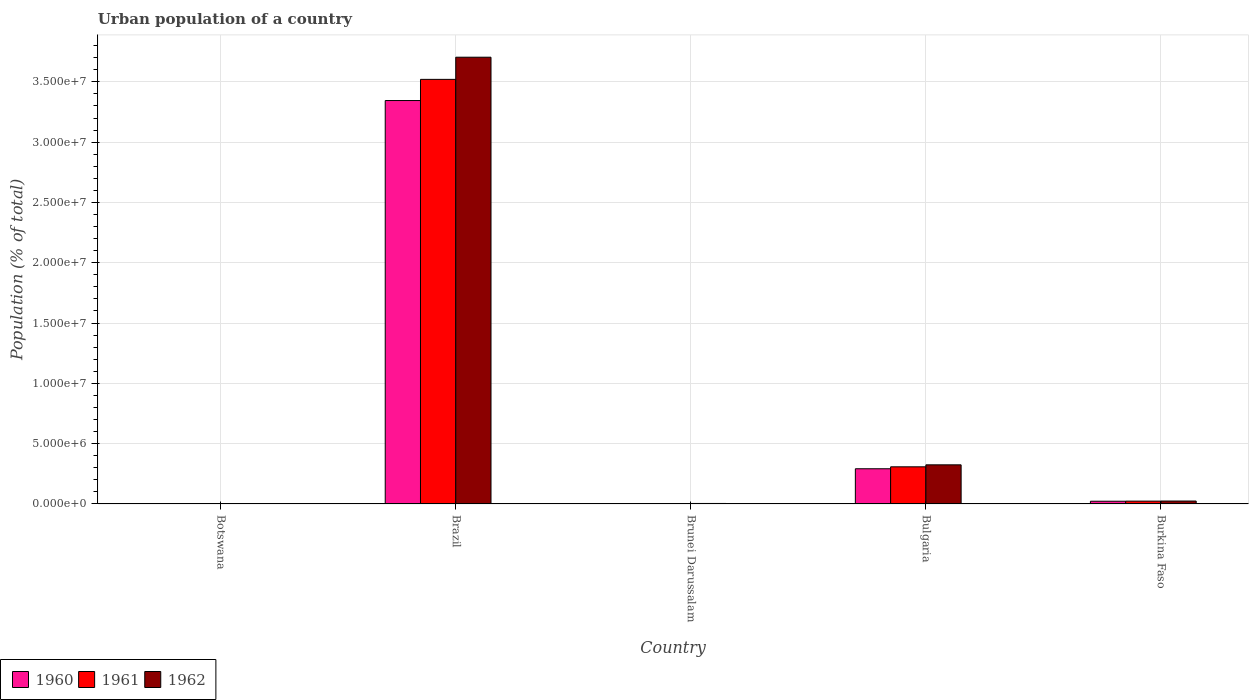How many different coloured bars are there?
Your answer should be very brief. 3. Are the number of bars on each tick of the X-axis equal?
Your answer should be very brief. Yes. What is the label of the 5th group of bars from the left?
Your answer should be compact. Burkina Faso. In how many cases, is the number of bars for a given country not equal to the number of legend labels?
Give a very brief answer. 0. What is the urban population in 1960 in Brunei Darussalam?
Keep it short and to the point. 3.55e+04. Across all countries, what is the maximum urban population in 1962?
Your answer should be compact. 3.70e+07. Across all countries, what is the minimum urban population in 1961?
Your answer should be very brief. 1.66e+04. In which country was the urban population in 1961 maximum?
Offer a very short reply. Brazil. In which country was the urban population in 1960 minimum?
Your answer should be very brief. Botswana. What is the total urban population in 1961 in the graph?
Offer a terse response. 3.86e+07. What is the difference between the urban population in 1961 in Botswana and that in Burkina Faso?
Your answer should be compact. -2.18e+05. What is the difference between the urban population in 1960 in Bulgaria and the urban population in 1961 in Botswana?
Provide a succinct answer. 2.90e+06. What is the average urban population in 1962 per country?
Ensure brevity in your answer.  8.12e+06. What is the difference between the urban population of/in 1962 and urban population of/in 1960 in Botswana?
Your response must be concise. 1202. What is the ratio of the urban population in 1961 in Botswana to that in Bulgaria?
Offer a terse response. 0.01. Is the urban population in 1962 in Botswana less than that in Bulgaria?
Give a very brief answer. Yes. Is the difference between the urban population in 1962 in Brunei Darussalam and Burkina Faso greater than the difference between the urban population in 1960 in Brunei Darussalam and Burkina Faso?
Provide a succinct answer. No. What is the difference between the highest and the second highest urban population in 1960?
Provide a short and direct response. -2.69e+06. What is the difference between the highest and the lowest urban population in 1962?
Your answer should be very brief. 3.70e+07. Is the sum of the urban population in 1960 in Botswana and Bulgaria greater than the maximum urban population in 1962 across all countries?
Offer a very short reply. No. What does the 3rd bar from the left in Bulgaria represents?
Your answer should be very brief. 1962. What does the 1st bar from the right in Bulgaria represents?
Make the answer very short. 1962. How many bars are there?
Provide a short and direct response. 15. Are all the bars in the graph horizontal?
Provide a succinct answer. No. How many countries are there in the graph?
Provide a short and direct response. 5. Does the graph contain any zero values?
Provide a succinct answer. No. How many legend labels are there?
Keep it short and to the point. 3. How are the legend labels stacked?
Provide a short and direct response. Horizontal. What is the title of the graph?
Offer a very short reply. Urban population of a country. What is the label or title of the X-axis?
Provide a succinct answer. Country. What is the label or title of the Y-axis?
Make the answer very short. Population (% of total). What is the Population (% of total) in 1960 in Botswana?
Provide a succinct answer. 1.60e+04. What is the Population (% of total) of 1961 in Botswana?
Your answer should be very brief. 1.66e+04. What is the Population (% of total) of 1962 in Botswana?
Your response must be concise. 1.72e+04. What is the Population (% of total) of 1960 in Brazil?
Offer a very short reply. 3.34e+07. What is the Population (% of total) in 1961 in Brazil?
Your answer should be very brief. 3.52e+07. What is the Population (% of total) of 1962 in Brazil?
Make the answer very short. 3.70e+07. What is the Population (% of total) in 1960 in Brunei Darussalam?
Offer a terse response. 3.55e+04. What is the Population (% of total) in 1961 in Brunei Darussalam?
Give a very brief answer. 3.88e+04. What is the Population (% of total) in 1962 in Brunei Darussalam?
Give a very brief answer. 4.22e+04. What is the Population (% of total) in 1960 in Bulgaria?
Offer a very short reply. 2.92e+06. What is the Population (% of total) of 1961 in Bulgaria?
Provide a succinct answer. 3.08e+06. What is the Population (% of total) in 1962 in Bulgaria?
Offer a very short reply. 3.24e+06. What is the Population (% of total) in 1960 in Burkina Faso?
Provide a succinct answer. 2.27e+05. What is the Population (% of total) of 1961 in Burkina Faso?
Keep it short and to the point. 2.35e+05. What is the Population (% of total) in 1962 in Burkina Faso?
Keep it short and to the point. 2.43e+05. Across all countries, what is the maximum Population (% of total) in 1960?
Keep it short and to the point. 3.34e+07. Across all countries, what is the maximum Population (% of total) in 1961?
Provide a short and direct response. 3.52e+07. Across all countries, what is the maximum Population (% of total) in 1962?
Provide a short and direct response. 3.70e+07. Across all countries, what is the minimum Population (% of total) of 1960?
Your response must be concise. 1.60e+04. Across all countries, what is the minimum Population (% of total) of 1961?
Offer a terse response. 1.66e+04. Across all countries, what is the minimum Population (% of total) of 1962?
Ensure brevity in your answer.  1.72e+04. What is the total Population (% of total) in 1960 in the graph?
Offer a very short reply. 3.66e+07. What is the total Population (% of total) of 1961 in the graph?
Offer a very short reply. 3.86e+07. What is the total Population (% of total) of 1962 in the graph?
Offer a very short reply. 4.06e+07. What is the difference between the Population (% of total) of 1960 in Botswana and that in Brazil?
Keep it short and to the point. -3.34e+07. What is the difference between the Population (% of total) of 1961 in Botswana and that in Brazil?
Your answer should be compact. -3.52e+07. What is the difference between the Population (% of total) in 1962 in Botswana and that in Brazil?
Your response must be concise. -3.70e+07. What is the difference between the Population (% of total) of 1960 in Botswana and that in Brunei Darussalam?
Ensure brevity in your answer.  -1.95e+04. What is the difference between the Population (% of total) in 1961 in Botswana and that in Brunei Darussalam?
Your answer should be compact. -2.21e+04. What is the difference between the Population (% of total) of 1962 in Botswana and that in Brunei Darussalam?
Give a very brief answer. -2.49e+04. What is the difference between the Population (% of total) in 1960 in Botswana and that in Bulgaria?
Keep it short and to the point. -2.90e+06. What is the difference between the Population (% of total) in 1961 in Botswana and that in Bulgaria?
Provide a succinct answer. -3.06e+06. What is the difference between the Population (% of total) of 1962 in Botswana and that in Bulgaria?
Your response must be concise. -3.23e+06. What is the difference between the Population (% of total) in 1960 in Botswana and that in Burkina Faso?
Keep it short and to the point. -2.11e+05. What is the difference between the Population (% of total) in 1961 in Botswana and that in Burkina Faso?
Offer a very short reply. -2.18e+05. What is the difference between the Population (% of total) of 1962 in Botswana and that in Burkina Faso?
Your answer should be very brief. -2.25e+05. What is the difference between the Population (% of total) of 1960 in Brazil and that in Brunei Darussalam?
Keep it short and to the point. 3.34e+07. What is the difference between the Population (% of total) in 1961 in Brazil and that in Brunei Darussalam?
Keep it short and to the point. 3.52e+07. What is the difference between the Population (% of total) in 1962 in Brazil and that in Brunei Darussalam?
Offer a very short reply. 3.70e+07. What is the difference between the Population (% of total) in 1960 in Brazil and that in Bulgaria?
Provide a short and direct response. 3.05e+07. What is the difference between the Population (% of total) in 1961 in Brazil and that in Bulgaria?
Your response must be concise. 3.21e+07. What is the difference between the Population (% of total) of 1962 in Brazil and that in Bulgaria?
Keep it short and to the point. 3.38e+07. What is the difference between the Population (% of total) of 1960 in Brazil and that in Burkina Faso?
Your response must be concise. 3.32e+07. What is the difference between the Population (% of total) in 1961 in Brazil and that in Burkina Faso?
Offer a terse response. 3.50e+07. What is the difference between the Population (% of total) of 1962 in Brazil and that in Burkina Faso?
Offer a terse response. 3.68e+07. What is the difference between the Population (% of total) of 1960 in Brunei Darussalam and that in Bulgaria?
Provide a short and direct response. -2.88e+06. What is the difference between the Population (% of total) of 1961 in Brunei Darussalam and that in Bulgaria?
Ensure brevity in your answer.  -3.04e+06. What is the difference between the Population (% of total) of 1962 in Brunei Darussalam and that in Bulgaria?
Give a very brief answer. -3.20e+06. What is the difference between the Population (% of total) of 1960 in Brunei Darussalam and that in Burkina Faso?
Your answer should be compact. -1.91e+05. What is the difference between the Population (% of total) in 1961 in Brunei Darussalam and that in Burkina Faso?
Offer a terse response. -1.96e+05. What is the difference between the Population (% of total) of 1962 in Brunei Darussalam and that in Burkina Faso?
Give a very brief answer. -2.01e+05. What is the difference between the Population (% of total) of 1960 in Bulgaria and that in Burkina Faso?
Your answer should be very brief. 2.69e+06. What is the difference between the Population (% of total) of 1961 in Bulgaria and that in Burkina Faso?
Your answer should be very brief. 2.85e+06. What is the difference between the Population (% of total) of 1962 in Bulgaria and that in Burkina Faso?
Give a very brief answer. 3.00e+06. What is the difference between the Population (% of total) of 1960 in Botswana and the Population (% of total) of 1961 in Brazil?
Your answer should be compact. -3.52e+07. What is the difference between the Population (% of total) of 1960 in Botswana and the Population (% of total) of 1962 in Brazil?
Offer a very short reply. -3.70e+07. What is the difference between the Population (% of total) of 1961 in Botswana and the Population (% of total) of 1962 in Brazil?
Your response must be concise. -3.70e+07. What is the difference between the Population (% of total) of 1960 in Botswana and the Population (% of total) of 1961 in Brunei Darussalam?
Your response must be concise. -2.27e+04. What is the difference between the Population (% of total) in 1960 in Botswana and the Population (% of total) in 1962 in Brunei Darussalam?
Provide a short and direct response. -2.61e+04. What is the difference between the Population (% of total) in 1961 in Botswana and the Population (% of total) in 1962 in Brunei Darussalam?
Provide a succinct answer. -2.56e+04. What is the difference between the Population (% of total) in 1960 in Botswana and the Population (% of total) in 1961 in Bulgaria?
Make the answer very short. -3.06e+06. What is the difference between the Population (% of total) of 1960 in Botswana and the Population (% of total) of 1962 in Bulgaria?
Keep it short and to the point. -3.23e+06. What is the difference between the Population (% of total) of 1961 in Botswana and the Population (% of total) of 1962 in Bulgaria?
Offer a terse response. -3.23e+06. What is the difference between the Population (% of total) of 1960 in Botswana and the Population (% of total) of 1961 in Burkina Faso?
Your answer should be very brief. -2.19e+05. What is the difference between the Population (% of total) of 1960 in Botswana and the Population (% of total) of 1962 in Burkina Faso?
Ensure brevity in your answer.  -2.27e+05. What is the difference between the Population (% of total) in 1961 in Botswana and the Population (% of total) in 1962 in Burkina Faso?
Keep it short and to the point. -2.26e+05. What is the difference between the Population (% of total) in 1960 in Brazil and the Population (% of total) in 1961 in Brunei Darussalam?
Provide a succinct answer. 3.34e+07. What is the difference between the Population (% of total) in 1960 in Brazil and the Population (% of total) in 1962 in Brunei Darussalam?
Keep it short and to the point. 3.34e+07. What is the difference between the Population (% of total) in 1961 in Brazil and the Population (% of total) in 1962 in Brunei Darussalam?
Offer a very short reply. 3.52e+07. What is the difference between the Population (% of total) of 1960 in Brazil and the Population (% of total) of 1961 in Bulgaria?
Provide a short and direct response. 3.04e+07. What is the difference between the Population (% of total) in 1960 in Brazil and the Population (% of total) in 1962 in Bulgaria?
Your answer should be compact. 3.02e+07. What is the difference between the Population (% of total) of 1961 in Brazil and the Population (% of total) of 1962 in Bulgaria?
Provide a succinct answer. 3.20e+07. What is the difference between the Population (% of total) in 1960 in Brazil and the Population (% of total) in 1961 in Burkina Faso?
Offer a very short reply. 3.32e+07. What is the difference between the Population (% of total) in 1960 in Brazil and the Population (% of total) in 1962 in Burkina Faso?
Make the answer very short. 3.32e+07. What is the difference between the Population (% of total) in 1961 in Brazil and the Population (% of total) in 1962 in Burkina Faso?
Provide a succinct answer. 3.50e+07. What is the difference between the Population (% of total) in 1960 in Brunei Darussalam and the Population (% of total) in 1961 in Bulgaria?
Make the answer very short. -3.04e+06. What is the difference between the Population (% of total) of 1960 in Brunei Darussalam and the Population (% of total) of 1962 in Bulgaria?
Provide a short and direct response. -3.21e+06. What is the difference between the Population (% of total) in 1961 in Brunei Darussalam and the Population (% of total) in 1962 in Bulgaria?
Provide a short and direct response. -3.21e+06. What is the difference between the Population (% of total) in 1960 in Brunei Darussalam and the Population (% of total) in 1961 in Burkina Faso?
Provide a short and direct response. -1.99e+05. What is the difference between the Population (% of total) in 1960 in Brunei Darussalam and the Population (% of total) in 1962 in Burkina Faso?
Your answer should be compact. -2.07e+05. What is the difference between the Population (% of total) in 1961 in Brunei Darussalam and the Population (% of total) in 1962 in Burkina Faso?
Your answer should be very brief. -2.04e+05. What is the difference between the Population (% of total) of 1960 in Bulgaria and the Population (% of total) of 1961 in Burkina Faso?
Provide a succinct answer. 2.68e+06. What is the difference between the Population (% of total) in 1960 in Bulgaria and the Population (% of total) in 1962 in Burkina Faso?
Make the answer very short. 2.68e+06. What is the difference between the Population (% of total) in 1961 in Bulgaria and the Population (% of total) in 1962 in Burkina Faso?
Your response must be concise. 2.84e+06. What is the average Population (% of total) in 1960 per country?
Offer a terse response. 7.33e+06. What is the average Population (% of total) in 1961 per country?
Provide a short and direct response. 7.71e+06. What is the average Population (% of total) in 1962 per country?
Provide a succinct answer. 8.12e+06. What is the difference between the Population (% of total) in 1960 and Population (% of total) in 1961 in Botswana?
Provide a short and direct response. -583. What is the difference between the Population (% of total) in 1960 and Population (% of total) in 1962 in Botswana?
Your response must be concise. -1202. What is the difference between the Population (% of total) of 1961 and Population (% of total) of 1962 in Botswana?
Offer a terse response. -619. What is the difference between the Population (% of total) of 1960 and Population (% of total) of 1961 in Brazil?
Your answer should be compact. -1.76e+06. What is the difference between the Population (% of total) of 1960 and Population (% of total) of 1962 in Brazil?
Make the answer very short. -3.59e+06. What is the difference between the Population (% of total) in 1961 and Population (% of total) in 1962 in Brazil?
Your response must be concise. -1.84e+06. What is the difference between the Population (% of total) in 1960 and Population (% of total) in 1961 in Brunei Darussalam?
Provide a short and direct response. -3242. What is the difference between the Population (% of total) of 1960 and Population (% of total) of 1962 in Brunei Darussalam?
Keep it short and to the point. -6663. What is the difference between the Population (% of total) of 1961 and Population (% of total) of 1962 in Brunei Darussalam?
Give a very brief answer. -3421. What is the difference between the Population (% of total) in 1960 and Population (% of total) in 1961 in Bulgaria?
Your response must be concise. -1.62e+05. What is the difference between the Population (% of total) of 1960 and Population (% of total) of 1962 in Bulgaria?
Give a very brief answer. -3.26e+05. What is the difference between the Population (% of total) in 1961 and Population (% of total) in 1962 in Bulgaria?
Provide a short and direct response. -1.64e+05. What is the difference between the Population (% of total) in 1960 and Population (% of total) in 1961 in Burkina Faso?
Give a very brief answer. -7767. What is the difference between the Population (% of total) of 1960 and Population (% of total) of 1962 in Burkina Faso?
Your answer should be compact. -1.57e+04. What is the difference between the Population (% of total) of 1961 and Population (% of total) of 1962 in Burkina Faso?
Your response must be concise. -7965. What is the ratio of the Population (% of total) of 1961 in Botswana to that in Brazil?
Give a very brief answer. 0. What is the ratio of the Population (% of total) in 1960 in Botswana to that in Brunei Darussalam?
Offer a terse response. 0.45. What is the ratio of the Population (% of total) in 1961 in Botswana to that in Brunei Darussalam?
Your answer should be very brief. 0.43. What is the ratio of the Population (% of total) of 1962 in Botswana to that in Brunei Darussalam?
Ensure brevity in your answer.  0.41. What is the ratio of the Population (% of total) of 1960 in Botswana to that in Bulgaria?
Your answer should be compact. 0.01. What is the ratio of the Population (% of total) of 1961 in Botswana to that in Bulgaria?
Your response must be concise. 0.01. What is the ratio of the Population (% of total) of 1962 in Botswana to that in Bulgaria?
Give a very brief answer. 0.01. What is the ratio of the Population (% of total) of 1960 in Botswana to that in Burkina Faso?
Your answer should be very brief. 0.07. What is the ratio of the Population (% of total) of 1961 in Botswana to that in Burkina Faso?
Keep it short and to the point. 0.07. What is the ratio of the Population (% of total) of 1962 in Botswana to that in Burkina Faso?
Offer a very short reply. 0.07. What is the ratio of the Population (% of total) in 1960 in Brazil to that in Brunei Darussalam?
Provide a short and direct response. 941.85. What is the ratio of the Population (% of total) in 1961 in Brazil to that in Brunei Darussalam?
Ensure brevity in your answer.  908.36. What is the ratio of the Population (% of total) of 1962 in Brazil to that in Brunei Darussalam?
Your answer should be compact. 878.22. What is the ratio of the Population (% of total) in 1960 in Brazil to that in Bulgaria?
Your answer should be compact. 11.46. What is the ratio of the Population (% of total) in 1961 in Brazil to that in Bulgaria?
Offer a very short reply. 11.43. What is the ratio of the Population (% of total) of 1962 in Brazil to that in Bulgaria?
Make the answer very short. 11.42. What is the ratio of the Population (% of total) in 1960 in Brazil to that in Burkina Faso?
Ensure brevity in your answer.  147.36. What is the ratio of the Population (% of total) in 1961 in Brazil to that in Burkina Faso?
Make the answer very short. 149.97. What is the ratio of the Population (% of total) of 1962 in Brazil to that in Burkina Faso?
Make the answer very short. 152.61. What is the ratio of the Population (% of total) in 1960 in Brunei Darussalam to that in Bulgaria?
Keep it short and to the point. 0.01. What is the ratio of the Population (% of total) of 1961 in Brunei Darussalam to that in Bulgaria?
Your response must be concise. 0.01. What is the ratio of the Population (% of total) of 1962 in Brunei Darussalam to that in Bulgaria?
Ensure brevity in your answer.  0.01. What is the ratio of the Population (% of total) in 1960 in Brunei Darussalam to that in Burkina Faso?
Offer a very short reply. 0.16. What is the ratio of the Population (% of total) in 1961 in Brunei Darussalam to that in Burkina Faso?
Your response must be concise. 0.17. What is the ratio of the Population (% of total) of 1962 in Brunei Darussalam to that in Burkina Faso?
Keep it short and to the point. 0.17. What is the ratio of the Population (% of total) of 1960 in Bulgaria to that in Burkina Faso?
Offer a terse response. 12.86. What is the ratio of the Population (% of total) of 1961 in Bulgaria to that in Burkina Faso?
Keep it short and to the point. 13.12. What is the ratio of the Population (% of total) in 1962 in Bulgaria to that in Burkina Faso?
Your response must be concise. 13.37. What is the difference between the highest and the second highest Population (% of total) in 1960?
Offer a terse response. 3.05e+07. What is the difference between the highest and the second highest Population (% of total) of 1961?
Provide a short and direct response. 3.21e+07. What is the difference between the highest and the second highest Population (% of total) in 1962?
Make the answer very short. 3.38e+07. What is the difference between the highest and the lowest Population (% of total) in 1960?
Provide a succinct answer. 3.34e+07. What is the difference between the highest and the lowest Population (% of total) in 1961?
Provide a short and direct response. 3.52e+07. What is the difference between the highest and the lowest Population (% of total) in 1962?
Your response must be concise. 3.70e+07. 